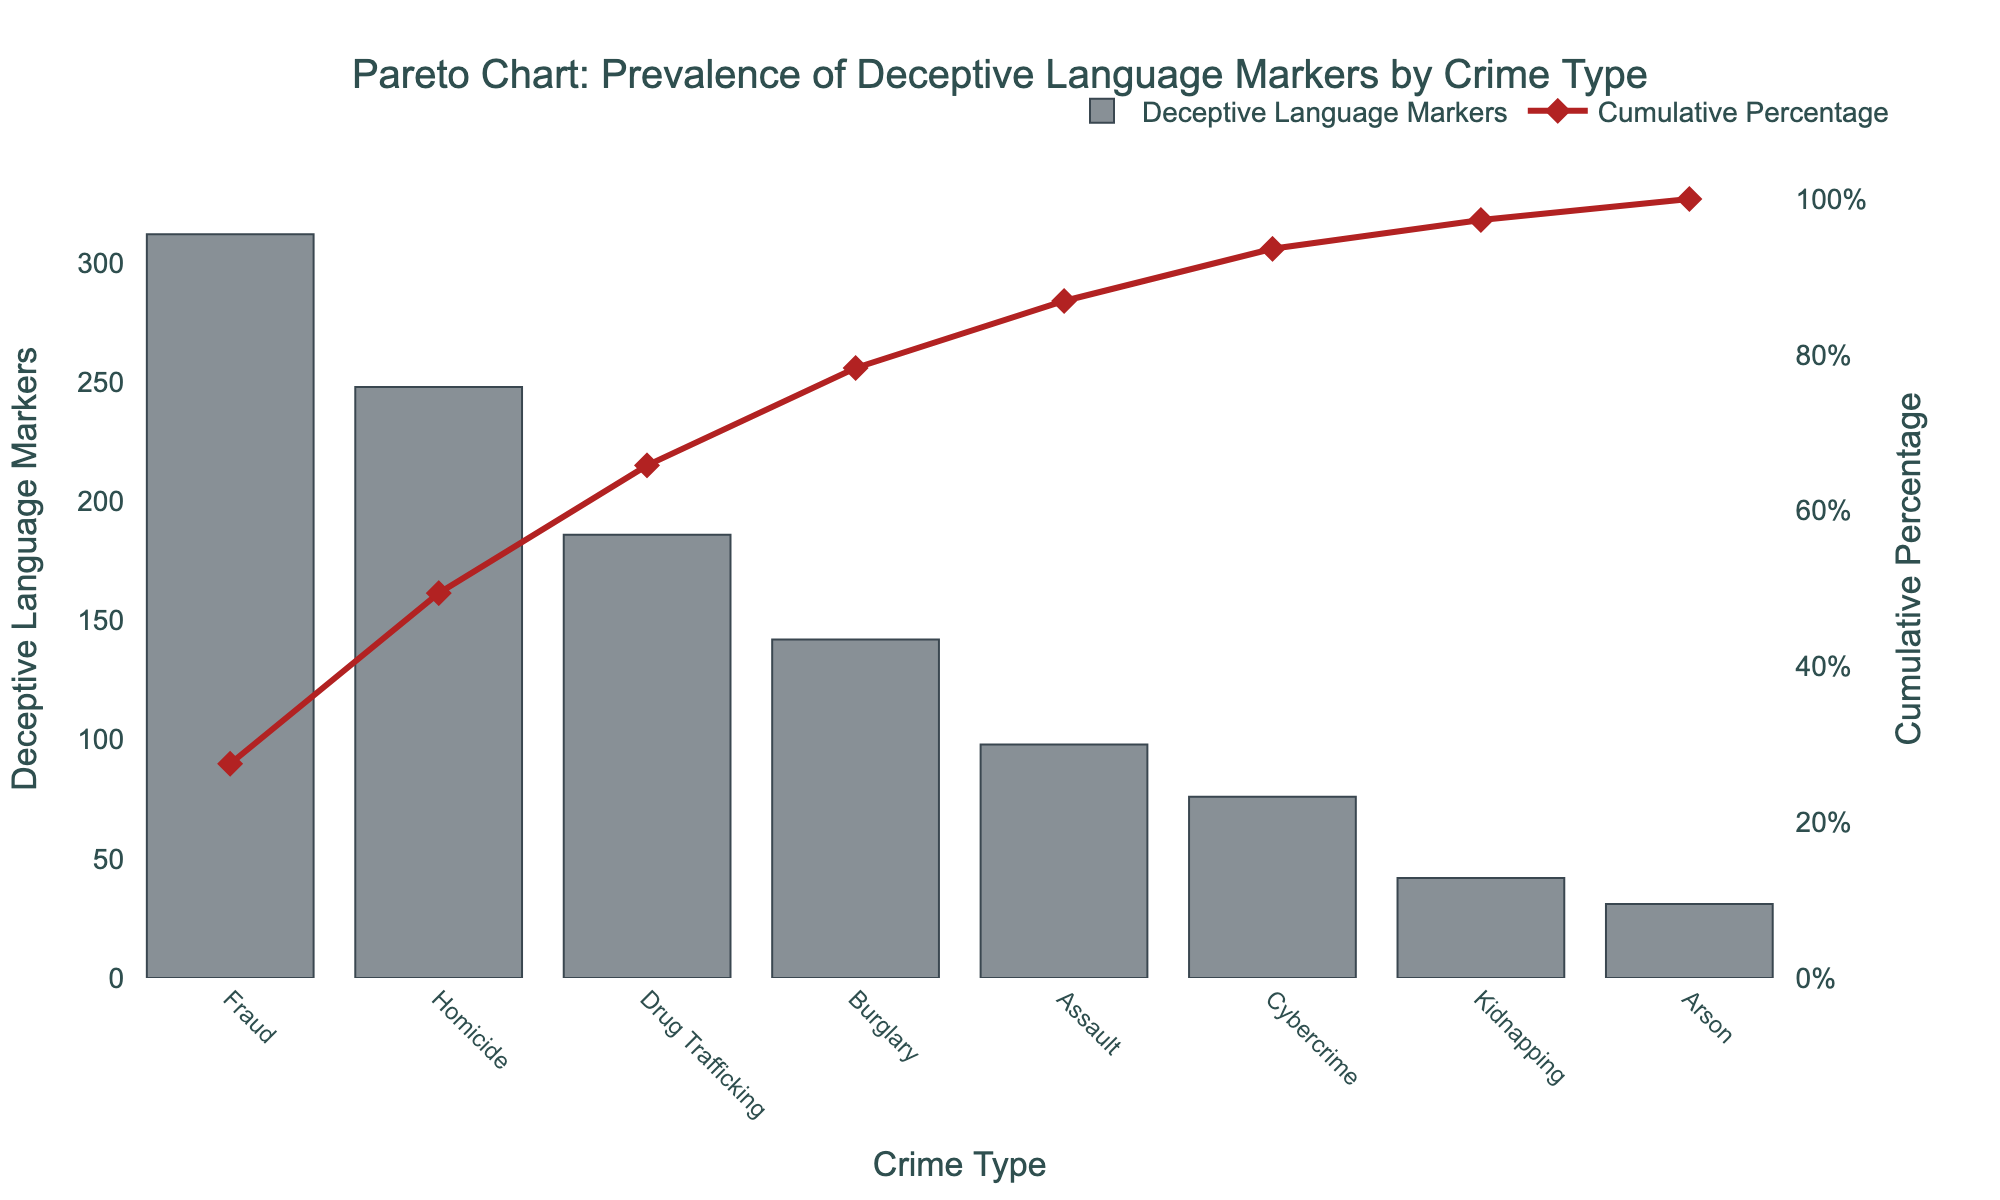How many data points are represented in the chart? Count the number of different crime types represented on the x-axis. There are 8 crime types listed.
Answer: 8 Which crime type has the highest number of deceptive language markers? Look for the highest bar on the chart. Fraud has the highest number of deceptive language markers with 312 markers.
Answer: Fraud What is the cumulative percentage after including the deceptive language markers for Homicide? Check the cumulative percentage value on the secondary y-axis corresponding to the point labeled "Homicide." The cumulative percentage is 49.4%.
Answer: 49.4% What is the exact number of deceptive language markers for Cybercrime? Locate the bar representing Cybercrime and note the value of the bar. The number of deceptive language markers for Cybercrime is 76.
Answer: 76 What is the difference in the number of deceptive language markers between Fraud and Arson? Subtract the number of deceptive language markers for Arson from the number for Fraud: 312 - 31 = 281.
Answer: 281 Which crime types account for over 65% of the cumulative deceptive language markers? Look for the point on the cumulative percentage line where it first exceeds 65%. Crime types up to and including Drug Trafficking account for 65.8%. These crime types are Fraud, Homicide, and Drug Trafficking.
Answer: Fraud, Homicide, Drug Trafficking What is the average number of deceptive language markers across all crime types? Sum all the deceptive language markers (312 + 248 + 186 + 142 + 98 + 76 + 42 + 31 = 1135) and divide by the number of crime types (8). So, the average is 1135 / 8 = 141.875.
Answer: 141.875 How many crime types have less than 100 deceptive language markers? Count the bars with values below 100. These are Cybercrime, Kidnapping, and Arson. There are 3 crime types.
Answer: 3 At which crime type does the cumulative percentage first exceed 85%? Check the cumulative percentage line and find when it first goes beyond 85%, which happens after Assault with 86.9%.
Answer: Assault Compare the number of deceptive language markers for Burglary and Kidnapping. Which is greater and by how much? Subtract the number of markers for Kidnapping from the number for Burglary: 142 - 42 = 100. Burglary has 100 more markers than Kidnapping.
Answer: Burglary, 100 